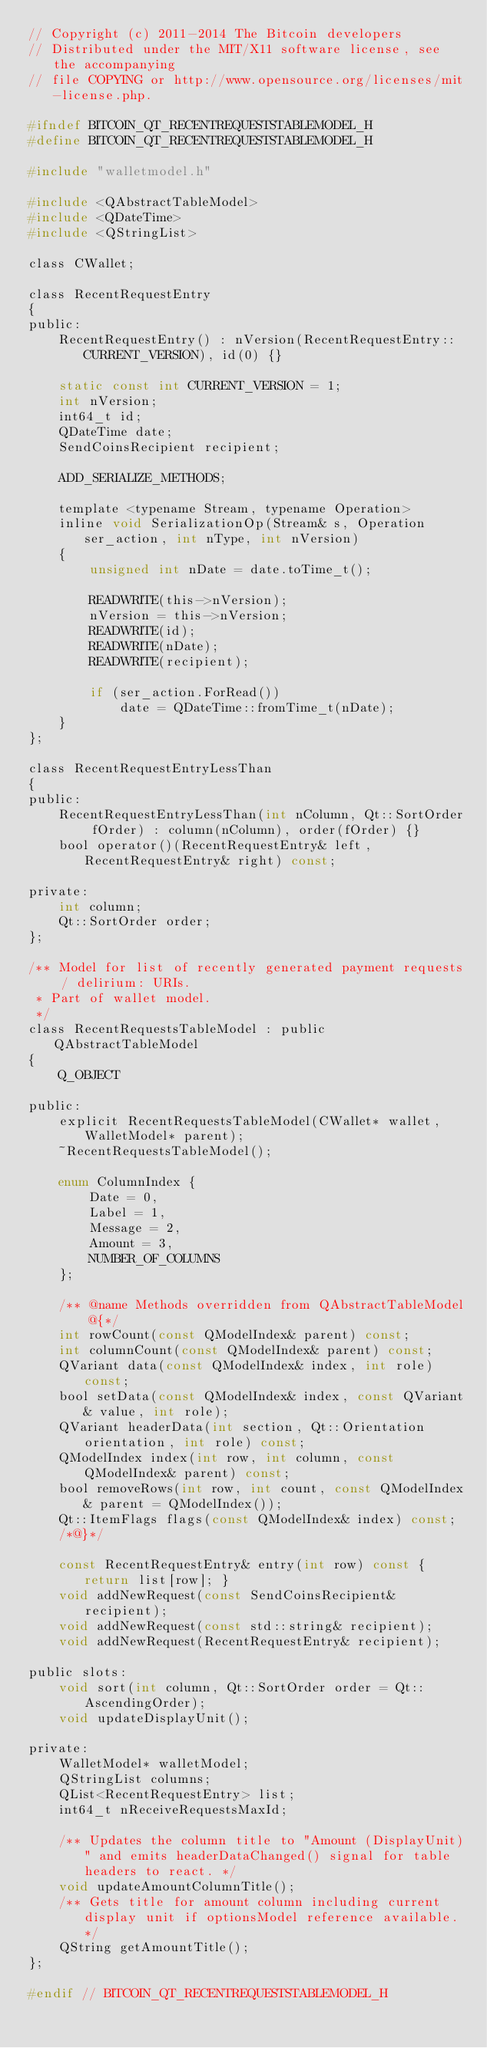Convert code to text. <code><loc_0><loc_0><loc_500><loc_500><_C_>// Copyright (c) 2011-2014 The Bitcoin developers
// Distributed under the MIT/X11 software license, see the accompanying
// file COPYING or http://www.opensource.org/licenses/mit-license.php.

#ifndef BITCOIN_QT_RECENTREQUESTSTABLEMODEL_H
#define BITCOIN_QT_RECENTREQUESTSTABLEMODEL_H

#include "walletmodel.h"

#include <QAbstractTableModel>
#include <QDateTime>
#include <QStringList>

class CWallet;

class RecentRequestEntry
{
public:
    RecentRequestEntry() : nVersion(RecentRequestEntry::CURRENT_VERSION), id(0) {}

    static const int CURRENT_VERSION = 1;
    int nVersion;
    int64_t id;
    QDateTime date;
    SendCoinsRecipient recipient;

    ADD_SERIALIZE_METHODS;

    template <typename Stream, typename Operation>
    inline void SerializationOp(Stream& s, Operation ser_action, int nType, int nVersion)
    {
        unsigned int nDate = date.toTime_t();

        READWRITE(this->nVersion);
        nVersion = this->nVersion;
        READWRITE(id);
        READWRITE(nDate);
        READWRITE(recipient);

        if (ser_action.ForRead())
            date = QDateTime::fromTime_t(nDate);
    }
};

class RecentRequestEntryLessThan
{
public:
    RecentRequestEntryLessThan(int nColumn, Qt::SortOrder fOrder) : column(nColumn), order(fOrder) {}
    bool operator()(RecentRequestEntry& left, RecentRequestEntry& right) const;

private:
    int column;
    Qt::SortOrder order;
};

/** Model for list of recently generated payment requests / delirium: URIs.
 * Part of wallet model.
 */
class RecentRequestsTableModel : public QAbstractTableModel
{
    Q_OBJECT

public:
    explicit RecentRequestsTableModel(CWallet* wallet, WalletModel* parent);
    ~RecentRequestsTableModel();

    enum ColumnIndex {
        Date = 0,
        Label = 1,
        Message = 2,
        Amount = 3,
        NUMBER_OF_COLUMNS
    };

    /** @name Methods overridden from QAbstractTableModel
        @{*/
    int rowCount(const QModelIndex& parent) const;
    int columnCount(const QModelIndex& parent) const;
    QVariant data(const QModelIndex& index, int role) const;
    bool setData(const QModelIndex& index, const QVariant& value, int role);
    QVariant headerData(int section, Qt::Orientation orientation, int role) const;
    QModelIndex index(int row, int column, const QModelIndex& parent) const;
    bool removeRows(int row, int count, const QModelIndex& parent = QModelIndex());
    Qt::ItemFlags flags(const QModelIndex& index) const;
    /*@}*/

    const RecentRequestEntry& entry(int row) const { return list[row]; }
    void addNewRequest(const SendCoinsRecipient& recipient);
    void addNewRequest(const std::string& recipient);
    void addNewRequest(RecentRequestEntry& recipient);

public slots:
    void sort(int column, Qt::SortOrder order = Qt::AscendingOrder);
    void updateDisplayUnit();

private:
    WalletModel* walletModel;
    QStringList columns;
    QList<RecentRequestEntry> list;
    int64_t nReceiveRequestsMaxId;

    /** Updates the column title to "Amount (DisplayUnit)" and emits headerDataChanged() signal for table headers to react. */
    void updateAmountColumnTitle();
    /** Gets title for amount column including current display unit if optionsModel reference available. */
    QString getAmountTitle();
};

#endif // BITCOIN_QT_RECENTREQUESTSTABLEMODEL_H
</code> 